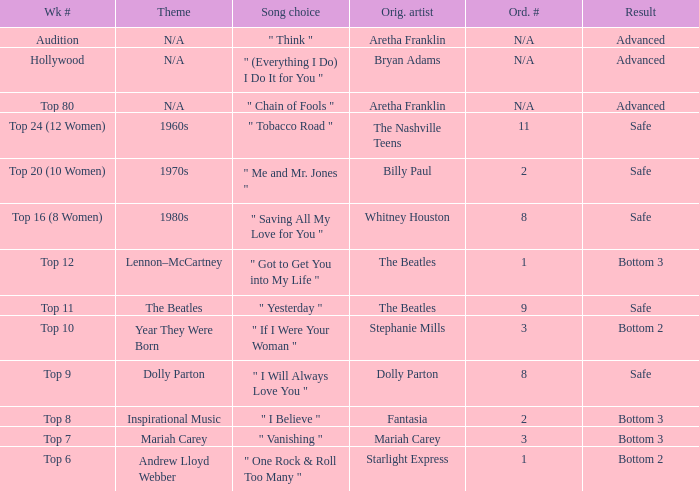Name the week number for andrew lloyd webber Top 6. Parse the table in full. {'header': ['Wk #', 'Theme', 'Song choice', 'Orig. artist', 'Ord. #', 'Result'], 'rows': [['Audition', 'N/A', '" Think "', 'Aretha Franklin', 'N/A', 'Advanced'], ['Hollywood', 'N/A', '" (Everything I Do) I Do It for You "', 'Bryan Adams', 'N/A', 'Advanced'], ['Top 80', 'N/A', '" Chain of Fools "', 'Aretha Franklin', 'N/A', 'Advanced'], ['Top 24 (12 Women)', '1960s', '" Tobacco Road "', 'The Nashville Teens', '11', 'Safe'], ['Top 20 (10 Women)', '1970s', '" Me and Mr. Jones "', 'Billy Paul', '2', 'Safe'], ['Top 16 (8 Women)', '1980s', '" Saving All My Love for You "', 'Whitney Houston', '8', 'Safe'], ['Top 12', 'Lennon–McCartney', '" Got to Get You into My Life "', 'The Beatles', '1', 'Bottom 3'], ['Top 11', 'The Beatles', '" Yesterday "', 'The Beatles', '9', 'Safe'], ['Top 10', 'Year They Were Born', '" If I Were Your Woman "', 'Stephanie Mills', '3', 'Bottom 2'], ['Top 9', 'Dolly Parton', '" I Will Always Love You "', 'Dolly Parton', '8', 'Safe'], ['Top 8', 'Inspirational Music', '" I Believe "', 'Fantasia', '2', 'Bottom 3'], ['Top 7', 'Mariah Carey', '" Vanishing "', 'Mariah Carey', '3', 'Bottom 3'], ['Top 6', 'Andrew Lloyd Webber', '" One Rock & Roll Too Many "', 'Starlight Express', '1', 'Bottom 2']]} 